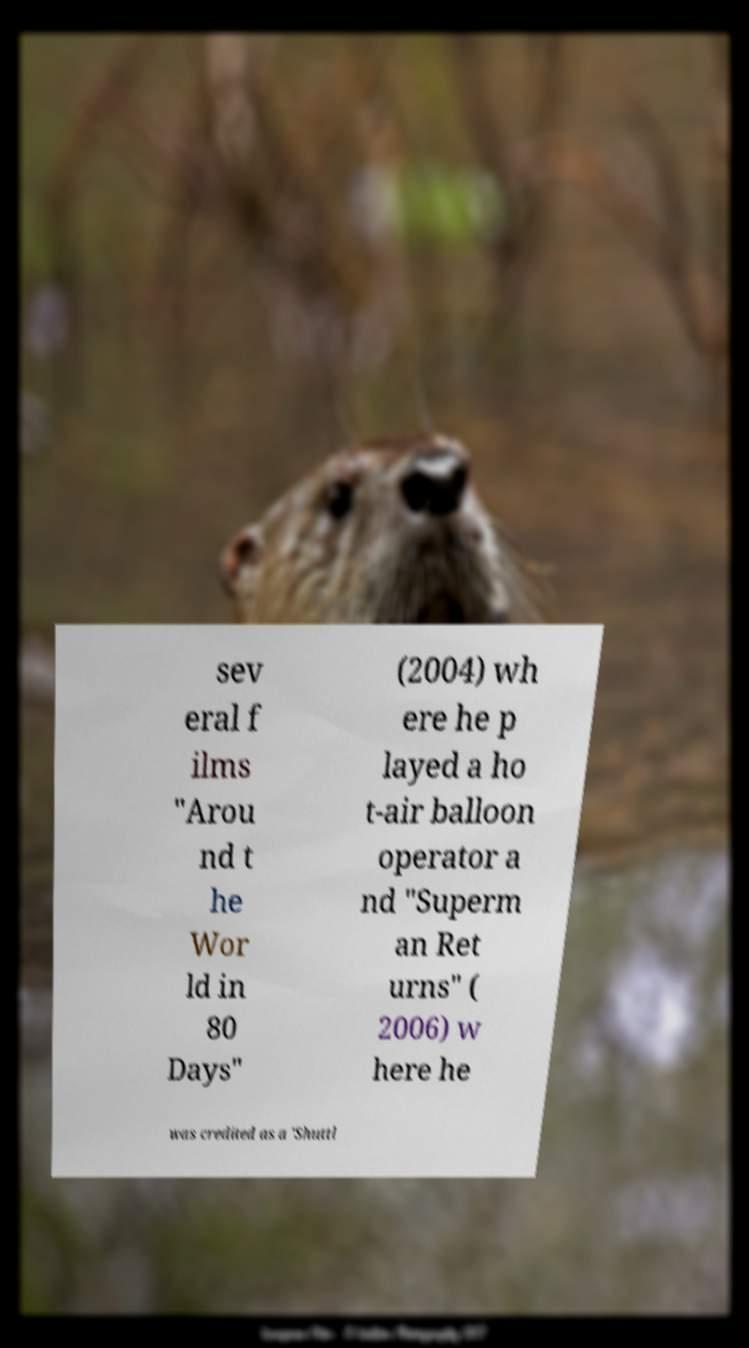There's text embedded in this image that I need extracted. Can you transcribe it verbatim? sev eral f ilms "Arou nd t he Wor ld in 80 Days" (2004) wh ere he p layed a ho t-air balloon operator a nd "Superm an Ret urns" ( 2006) w here he was credited as a 'Shuttl 